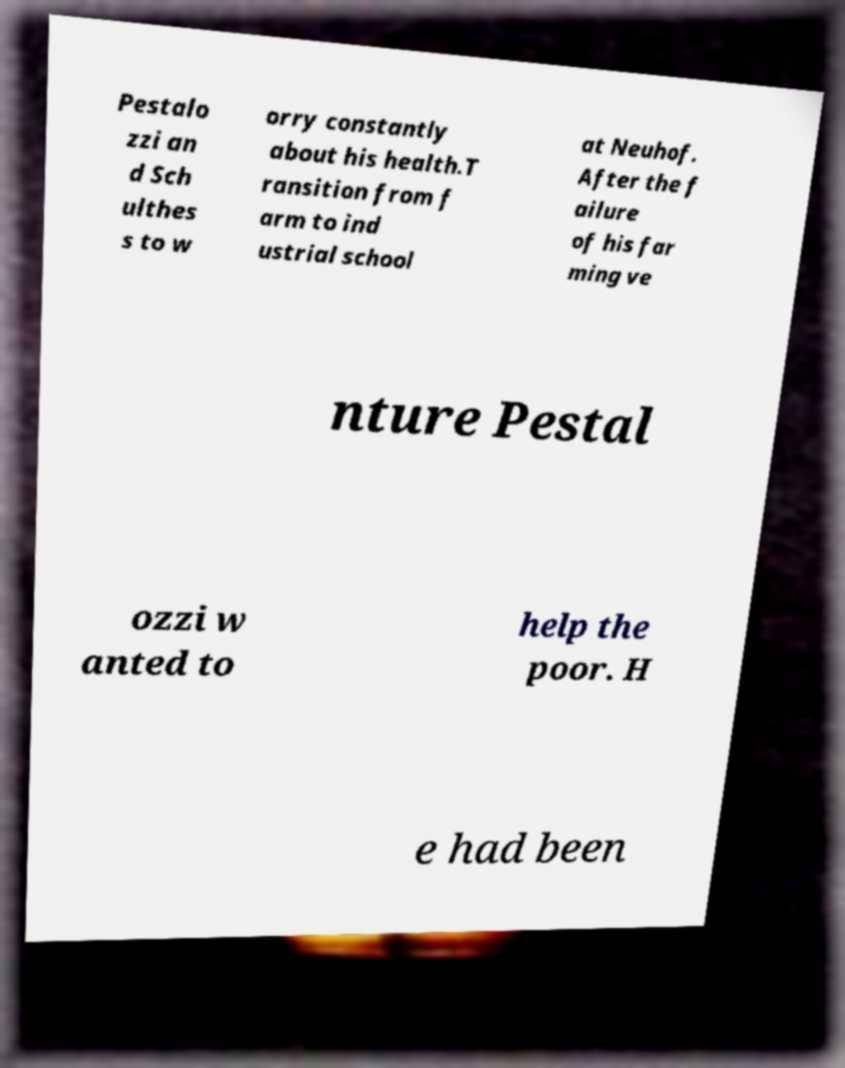Can you accurately transcribe the text from the provided image for me? Pestalo zzi an d Sch ulthes s to w orry constantly about his health.T ransition from f arm to ind ustrial school at Neuhof. After the f ailure of his far ming ve nture Pestal ozzi w anted to help the poor. H e had been 